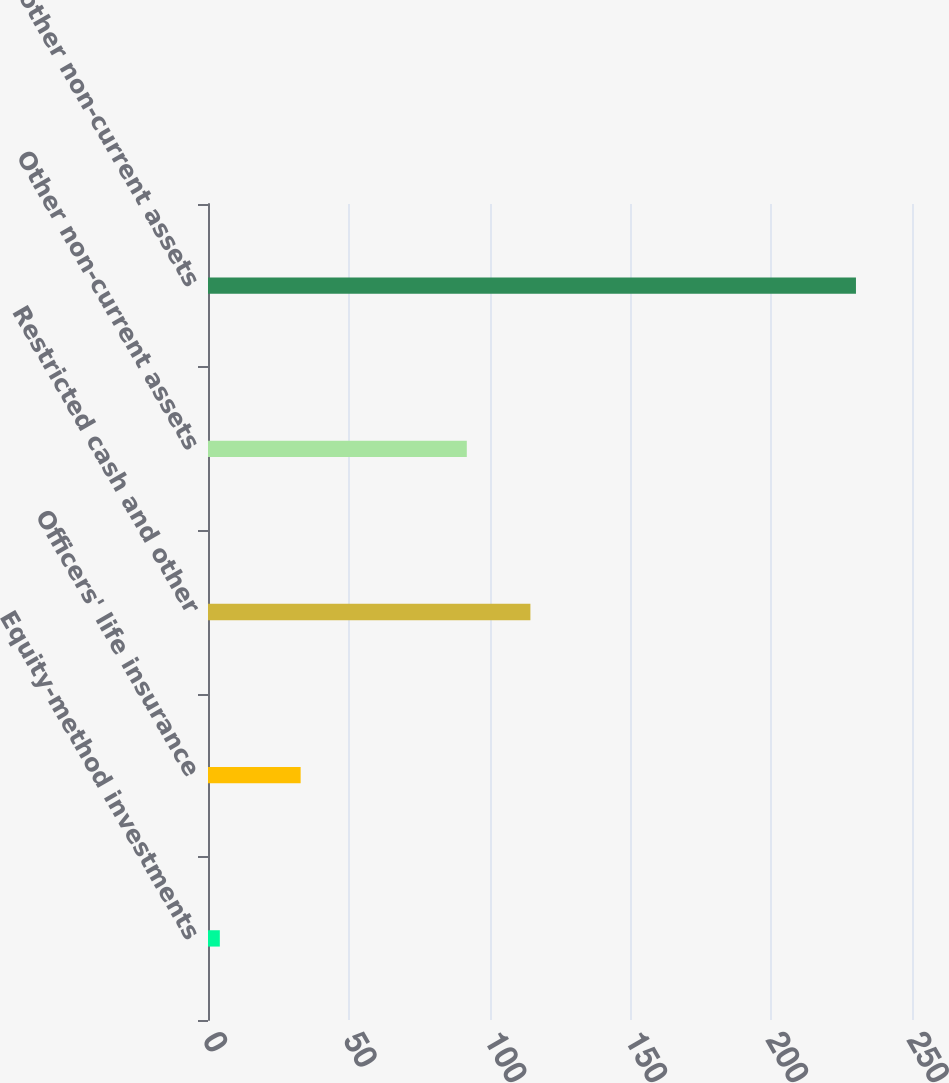Convert chart to OTSL. <chart><loc_0><loc_0><loc_500><loc_500><bar_chart><fcel>Equity-method investments<fcel>Officers' life insurance<fcel>Restricted cash and other<fcel>Other non-current assets<fcel>Total other non-current assets<nl><fcel>4.2<fcel>32.9<fcel>114.49<fcel>91.9<fcel>230.1<nl></chart> 